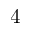<formula> <loc_0><loc_0><loc_500><loc_500>4</formula> 